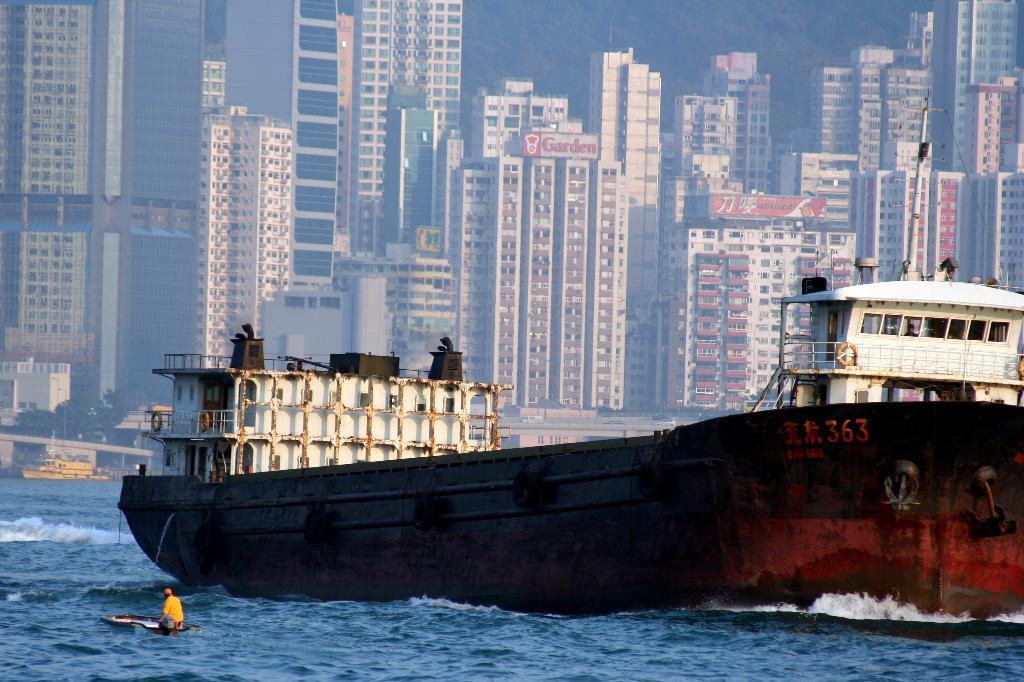What is the main subject in the foreground of the image? There is a ship in the foreground of the image. Can you describe the person on the ship? A man is on the boat. Where is the ship and the man located? The ship and the man are on the water. What can be seen in the background of the image? There are many buildings and another ship in the background of the image. How does the man use a fork to eat while on the ship? There is no fork present in the image, so it is not possible to answer that question. 